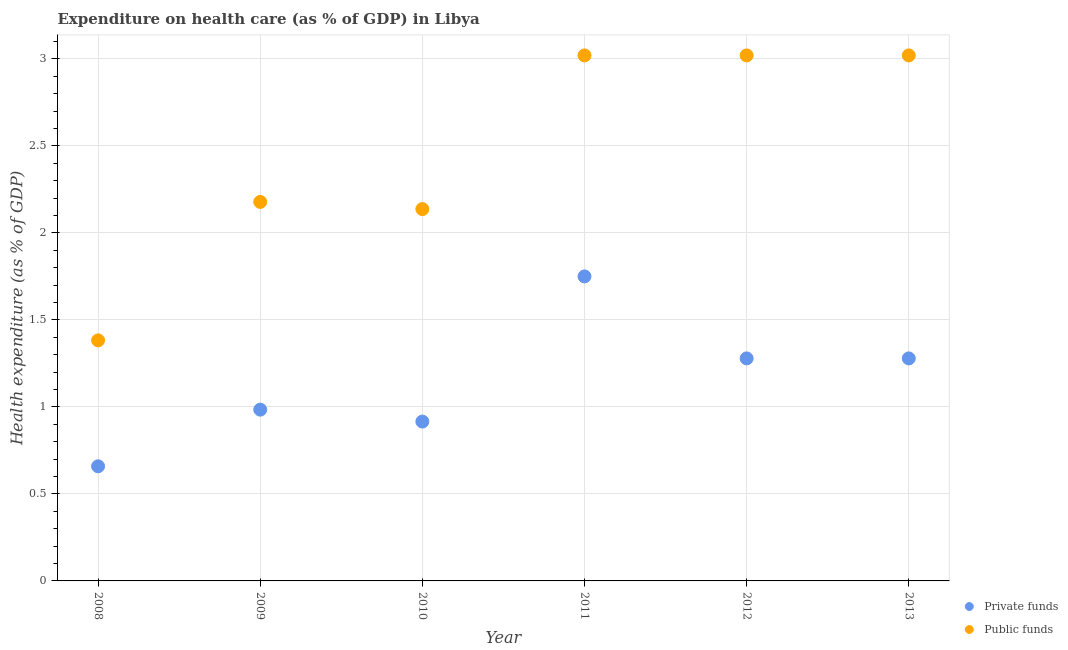How many different coloured dotlines are there?
Your answer should be compact. 2. What is the amount of public funds spent in healthcare in 2013?
Ensure brevity in your answer.  3.02. Across all years, what is the maximum amount of public funds spent in healthcare?
Your answer should be compact. 3.02. Across all years, what is the minimum amount of public funds spent in healthcare?
Offer a terse response. 1.38. In which year was the amount of public funds spent in healthcare maximum?
Give a very brief answer. 2012. In which year was the amount of private funds spent in healthcare minimum?
Give a very brief answer. 2008. What is the total amount of public funds spent in healthcare in the graph?
Offer a very short reply. 14.76. What is the difference between the amount of private funds spent in healthcare in 2008 and that in 2010?
Ensure brevity in your answer.  -0.26. What is the difference between the amount of private funds spent in healthcare in 2012 and the amount of public funds spent in healthcare in 2009?
Give a very brief answer. -0.9. What is the average amount of private funds spent in healthcare per year?
Your answer should be compact. 1.14. In the year 2008, what is the difference between the amount of public funds spent in healthcare and amount of private funds spent in healthcare?
Your answer should be very brief. 0.72. What is the ratio of the amount of private funds spent in healthcare in 2008 to that in 2012?
Provide a succinct answer. 0.52. What is the difference between the highest and the second highest amount of private funds spent in healthcare?
Offer a very short reply. 0.47. What is the difference between the highest and the lowest amount of private funds spent in healthcare?
Provide a succinct answer. 1.09. In how many years, is the amount of private funds spent in healthcare greater than the average amount of private funds spent in healthcare taken over all years?
Provide a short and direct response. 3. Does the amount of private funds spent in healthcare monotonically increase over the years?
Your answer should be compact. No. Is the amount of public funds spent in healthcare strictly greater than the amount of private funds spent in healthcare over the years?
Offer a terse response. Yes. Is the amount of private funds spent in healthcare strictly less than the amount of public funds spent in healthcare over the years?
Offer a terse response. Yes. How many years are there in the graph?
Offer a very short reply. 6. Are the values on the major ticks of Y-axis written in scientific E-notation?
Your response must be concise. No. Does the graph contain any zero values?
Make the answer very short. No. What is the title of the graph?
Give a very brief answer. Expenditure on health care (as % of GDP) in Libya. Does "Nitrous oxide emissions" appear as one of the legend labels in the graph?
Keep it short and to the point. No. What is the label or title of the X-axis?
Provide a short and direct response. Year. What is the label or title of the Y-axis?
Your response must be concise. Health expenditure (as % of GDP). What is the Health expenditure (as % of GDP) in Private funds in 2008?
Offer a terse response. 0.66. What is the Health expenditure (as % of GDP) in Public funds in 2008?
Your answer should be compact. 1.38. What is the Health expenditure (as % of GDP) of Private funds in 2009?
Offer a very short reply. 0.98. What is the Health expenditure (as % of GDP) in Public funds in 2009?
Ensure brevity in your answer.  2.18. What is the Health expenditure (as % of GDP) in Private funds in 2010?
Your answer should be very brief. 0.92. What is the Health expenditure (as % of GDP) of Public funds in 2010?
Offer a terse response. 2.14. What is the Health expenditure (as % of GDP) in Private funds in 2011?
Make the answer very short. 1.75. What is the Health expenditure (as % of GDP) in Public funds in 2011?
Offer a terse response. 3.02. What is the Health expenditure (as % of GDP) in Private funds in 2012?
Your answer should be compact. 1.28. What is the Health expenditure (as % of GDP) of Public funds in 2012?
Offer a very short reply. 3.02. What is the Health expenditure (as % of GDP) in Private funds in 2013?
Keep it short and to the point. 1.28. What is the Health expenditure (as % of GDP) of Public funds in 2013?
Offer a very short reply. 3.02. Across all years, what is the maximum Health expenditure (as % of GDP) of Private funds?
Provide a short and direct response. 1.75. Across all years, what is the maximum Health expenditure (as % of GDP) of Public funds?
Keep it short and to the point. 3.02. Across all years, what is the minimum Health expenditure (as % of GDP) of Private funds?
Offer a very short reply. 0.66. Across all years, what is the minimum Health expenditure (as % of GDP) in Public funds?
Your response must be concise. 1.38. What is the total Health expenditure (as % of GDP) of Private funds in the graph?
Provide a short and direct response. 6.87. What is the total Health expenditure (as % of GDP) of Public funds in the graph?
Provide a succinct answer. 14.76. What is the difference between the Health expenditure (as % of GDP) of Private funds in 2008 and that in 2009?
Provide a short and direct response. -0.33. What is the difference between the Health expenditure (as % of GDP) in Public funds in 2008 and that in 2009?
Make the answer very short. -0.8. What is the difference between the Health expenditure (as % of GDP) of Private funds in 2008 and that in 2010?
Offer a very short reply. -0.26. What is the difference between the Health expenditure (as % of GDP) of Public funds in 2008 and that in 2010?
Make the answer very short. -0.75. What is the difference between the Health expenditure (as % of GDP) of Private funds in 2008 and that in 2011?
Provide a succinct answer. -1.09. What is the difference between the Health expenditure (as % of GDP) of Public funds in 2008 and that in 2011?
Your answer should be very brief. -1.64. What is the difference between the Health expenditure (as % of GDP) in Private funds in 2008 and that in 2012?
Give a very brief answer. -0.62. What is the difference between the Health expenditure (as % of GDP) of Public funds in 2008 and that in 2012?
Offer a terse response. -1.64. What is the difference between the Health expenditure (as % of GDP) in Private funds in 2008 and that in 2013?
Provide a short and direct response. -0.62. What is the difference between the Health expenditure (as % of GDP) of Public funds in 2008 and that in 2013?
Keep it short and to the point. -1.64. What is the difference between the Health expenditure (as % of GDP) in Private funds in 2009 and that in 2010?
Offer a terse response. 0.07. What is the difference between the Health expenditure (as % of GDP) of Public funds in 2009 and that in 2010?
Your answer should be very brief. 0.04. What is the difference between the Health expenditure (as % of GDP) in Private funds in 2009 and that in 2011?
Your response must be concise. -0.77. What is the difference between the Health expenditure (as % of GDP) in Public funds in 2009 and that in 2011?
Your answer should be compact. -0.84. What is the difference between the Health expenditure (as % of GDP) in Private funds in 2009 and that in 2012?
Provide a succinct answer. -0.29. What is the difference between the Health expenditure (as % of GDP) of Public funds in 2009 and that in 2012?
Make the answer very short. -0.84. What is the difference between the Health expenditure (as % of GDP) in Private funds in 2009 and that in 2013?
Offer a terse response. -0.29. What is the difference between the Health expenditure (as % of GDP) of Public funds in 2009 and that in 2013?
Provide a short and direct response. -0.84. What is the difference between the Health expenditure (as % of GDP) in Private funds in 2010 and that in 2011?
Your answer should be compact. -0.83. What is the difference between the Health expenditure (as % of GDP) of Public funds in 2010 and that in 2011?
Provide a short and direct response. -0.88. What is the difference between the Health expenditure (as % of GDP) of Private funds in 2010 and that in 2012?
Offer a terse response. -0.36. What is the difference between the Health expenditure (as % of GDP) in Public funds in 2010 and that in 2012?
Provide a short and direct response. -0.88. What is the difference between the Health expenditure (as % of GDP) in Private funds in 2010 and that in 2013?
Provide a short and direct response. -0.36. What is the difference between the Health expenditure (as % of GDP) in Public funds in 2010 and that in 2013?
Your answer should be very brief. -0.88. What is the difference between the Health expenditure (as % of GDP) of Private funds in 2011 and that in 2012?
Provide a short and direct response. 0.47. What is the difference between the Health expenditure (as % of GDP) of Private funds in 2011 and that in 2013?
Your answer should be compact. 0.47. What is the difference between the Health expenditure (as % of GDP) in Public funds in 2012 and that in 2013?
Ensure brevity in your answer.  0. What is the difference between the Health expenditure (as % of GDP) of Private funds in 2008 and the Health expenditure (as % of GDP) of Public funds in 2009?
Offer a terse response. -1.52. What is the difference between the Health expenditure (as % of GDP) of Private funds in 2008 and the Health expenditure (as % of GDP) of Public funds in 2010?
Give a very brief answer. -1.48. What is the difference between the Health expenditure (as % of GDP) in Private funds in 2008 and the Health expenditure (as % of GDP) in Public funds in 2011?
Your response must be concise. -2.36. What is the difference between the Health expenditure (as % of GDP) in Private funds in 2008 and the Health expenditure (as % of GDP) in Public funds in 2012?
Keep it short and to the point. -2.36. What is the difference between the Health expenditure (as % of GDP) of Private funds in 2008 and the Health expenditure (as % of GDP) of Public funds in 2013?
Make the answer very short. -2.36. What is the difference between the Health expenditure (as % of GDP) in Private funds in 2009 and the Health expenditure (as % of GDP) in Public funds in 2010?
Your response must be concise. -1.15. What is the difference between the Health expenditure (as % of GDP) in Private funds in 2009 and the Health expenditure (as % of GDP) in Public funds in 2011?
Make the answer very short. -2.04. What is the difference between the Health expenditure (as % of GDP) of Private funds in 2009 and the Health expenditure (as % of GDP) of Public funds in 2012?
Make the answer very short. -2.04. What is the difference between the Health expenditure (as % of GDP) of Private funds in 2009 and the Health expenditure (as % of GDP) of Public funds in 2013?
Ensure brevity in your answer.  -2.04. What is the difference between the Health expenditure (as % of GDP) in Private funds in 2010 and the Health expenditure (as % of GDP) in Public funds in 2011?
Keep it short and to the point. -2.1. What is the difference between the Health expenditure (as % of GDP) of Private funds in 2010 and the Health expenditure (as % of GDP) of Public funds in 2012?
Your response must be concise. -2.1. What is the difference between the Health expenditure (as % of GDP) in Private funds in 2010 and the Health expenditure (as % of GDP) in Public funds in 2013?
Your response must be concise. -2.1. What is the difference between the Health expenditure (as % of GDP) of Private funds in 2011 and the Health expenditure (as % of GDP) of Public funds in 2012?
Your answer should be compact. -1.27. What is the difference between the Health expenditure (as % of GDP) in Private funds in 2011 and the Health expenditure (as % of GDP) in Public funds in 2013?
Your answer should be very brief. -1.27. What is the difference between the Health expenditure (as % of GDP) in Private funds in 2012 and the Health expenditure (as % of GDP) in Public funds in 2013?
Ensure brevity in your answer.  -1.74. What is the average Health expenditure (as % of GDP) in Private funds per year?
Give a very brief answer. 1.14. What is the average Health expenditure (as % of GDP) of Public funds per year?
Your answer should be compact. 2.46. In the year 2008, what is the difference between the Health expenditure (as % of GDP) of Private funds and Health expenditure (as % of GDP) of Public funds?
Your response must be concise. -0.72. In the year 2009, what is the difference between the Health expenditure (as % of GDP) of Private funds and Health expenditure (as % of GDP) of Public funds?
Provide a short and direct response. -1.19. In the year 2010, what is the difference between the Health expenditure (as % of GDP) in Private funds and Health expenditure (as % of GDP) in Public funds?
Your response must be concise. -1.22. In the year 2011, what is the difference between the Health expenditure (as % of GDP) of Private funds and Health expenditure (as % of GDP) of Public funds?
Make the answer very short. -1.27. In the year 2012, what is the difference between the Health expenditure (as % of GDP) of Private funds and Health expenditure (as % of GDP) of Public funds?
Give a very brief answer. -1.74. In the year 2013, what is the difference between the Health expenditure (as % of GDP) in Private funds and Health expenditure (as % of GDP) in Public funds?
Provide a succinct answer. -1.74. What is the ratio of the Health expenditure (as % of GDP) of Private funds in 2008 to that in 2009?
Ensure brevity in your answer.  0.67. What is the ratio of the Health expenditure (as % of GDP) in Public funds in 2008 to that in 2009?
Provide a succinct answer. 0.63. What is the ratio of the Health expenditure (as % of GDP) of Private funds in 2008 to that in 2010?
Your answer should be very brief. 0.72. What is the ratio of the Health expenditure (as % of GDP) in Public funds in 2008 to that in 2010?
Offer a very short reply. 0.65. What is the ratio of the Health expenditure (as % of GDP) in Private funds in 2008 to that in 2011?
Your answer should be compact. 0.38. What is the ratio of the Health expenditure (as % of GDP) in Public funds in 2008 to that in 2011?
Your answer should be compact. 0.46. What is the ratio of the Health expenditure (as % of GDP) of Private funds in 2008 to that in 2012?
Your answer should be compact. 0.52. What is the ratio of the Health expenditure (as % of GDP) in Public funds in 2008 to that in 2012?
Offer a terse response. 0.46. What is the ratio of the Health expenditure (as % of GDP) in Private funds in 2008 to that in 2013?
Your answer should be very brief. 0.52. What is the ratio of the Health expenditure (as % of GDP) in Public funds in 2008 to that in 2013?
Provide a succinct answer. 0.46. What is the ratio of the Health expenditure (as % of GDP) of Private funds in 2009 to that in 2010?
Give a very brief answer. 1.07. What is the ratio of the Health expenditure (as % of GDP) of Public funds in 2009 to that in 2010?
Your response must be concise. 1.02. What is the ratio of the Health expenditure (as % of GDP) in Private funds in 2009 to that in 2011?
Give a very brief answer. 0.56. What is the ratio of the Health expenditure (as % of GDP) of Public funds in 2009 to that in 2011?
Provide a short and direct response. 0.72. What is the ratio of the Health expenditure (as % of GDP) in Private funds in 2009 to that in 2012?
Your answer should be compact. 0.77. What is the ratio of the Health expenditure (as % of GDP) in Public funds in 2009 to that in 2012?
Your response must be concise. 0.72. What is the ratio of the Health expenditure (as % of GDP) of Private funds in 2009 to that in 2013?
Keep it short and to the point. 0.77. What is the ratio of the Health expenditure (as % of GDP) of Public funds in 2009 to that in 2013?
Make the answer very short. 0.72. What is the ratio of the Health expenditure (as % of GDP) of Private funds in 2010 to that in 2011?
Provide a succinct answer. 0.52. What is the ratio of the Health expenditure (as % of GDP) in Public funds in 2010 to that in 2011?
Provide a succinct answer. 0.71. What is the ratio of the Health expenditure (as % of GDP) of Private funds in 2010 to that in 2012?
Your response must be concise. 0.72. What is the ratio of the Health expenditure (as % of GDP) of Public funds in 2010 to that in 2012?
Your answer should be compact. 0.71. What is the ratio of the Health expenditure (as % of GDP) in Private funds in 2010 to that in 2013?
Ensure brevity in your answer.  0.72. What is the ratio of the Health expenditure (as % of GDP) in Public funds in 2010 to that in 2013?
Give a very brief answer. 0.71. What is the ratio of the Health expenditure (as % of GDP) of Private funds in 2011 to that in 2012?
Make the answer very short. 1.37. What is the ratio of the Health expenditure (as % of GDP) of Public funds in 2011 to that in 2012?
Provide a short and direct response. 1. What is the ratio of the Health expenditure (as % of GDP) of Private funds in 2011 to that in 2013?
Keep it short and to the point. 1.37. What is the ratio of the Health expenditure (as % of GDP) of Public funds in 2011 to that in 2013?
Your answer should be compact. 1. What is the ratio of the Health expenditure (as % of GDP) in Public funds in 2012 to that in 2013?
Give a very brief answer. 1. What is the difference between the highest and the second highest Health expenditure (as % of GDP) of Private funds?
Keep it short and to the point. 0.47. What is the difference between the highest and the second highest Health expenditure (as % of GDP) in Public funds?
Keep it short and to the point. 0. What is the difference between the highest and the lowest Health expenditure (as % of GDP) of Private funds?
Your answer should be compact. 1.09. What is the difference between the highest and the lowest Health expenditure (as % of GDP) in Public funds?
Provide a short and direct response. 1.64. 